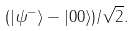Convert formula to latex. <formula><loc_0><loc_0><loc_500><loc_500>( | \psi ^ { - } \rangle - | 0 0 \rangle ) / { \sqrt { 2 } } .</formula> 